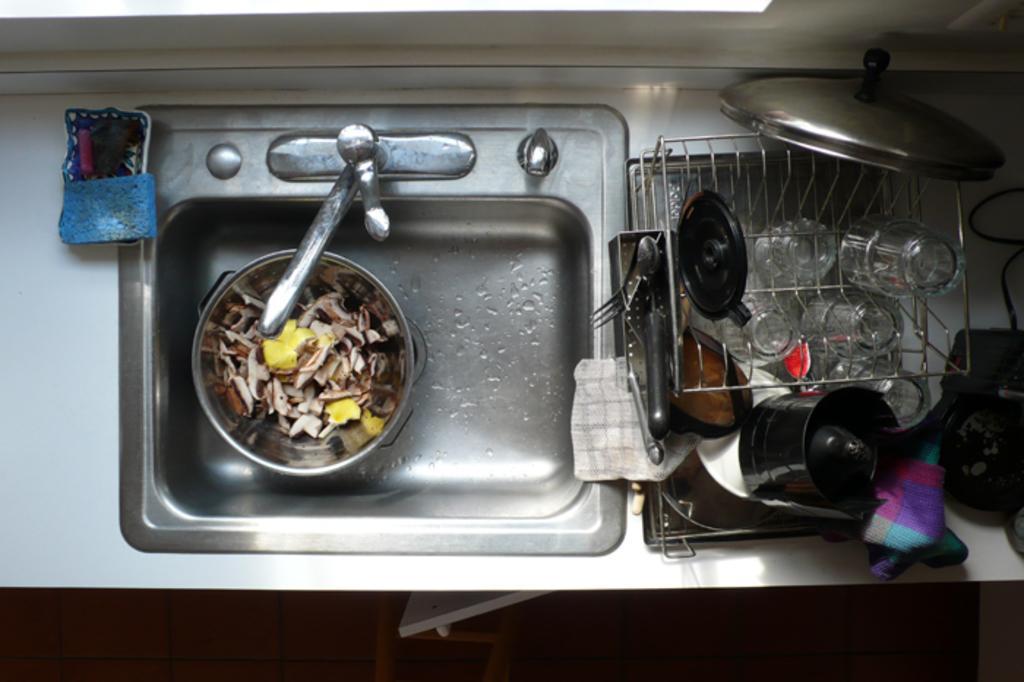Please provide a concise description of this image. In the picture we can see a sink with a tap, in the sink we can see a bowl with some things in it and beside the sink we can see a detergent which is blue in color and to the other side we can see some glasses, plates and pans in the stand and we can also see a cloth. 